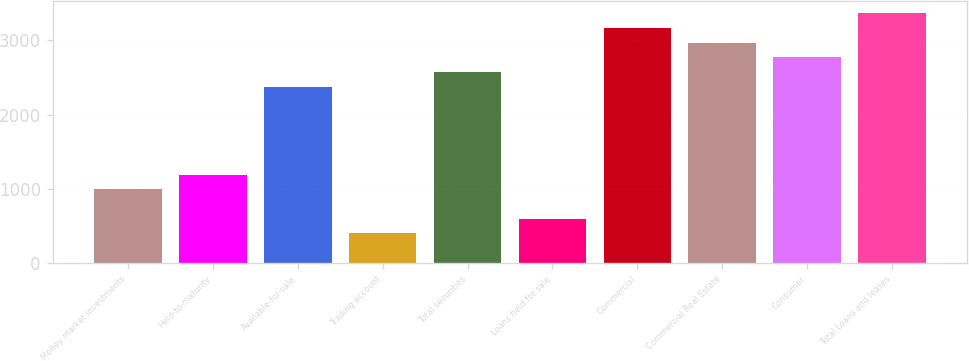Convert chart. <chart><loc_0><loc_0><loc_500><loc_500><bar_chart><fcel>Money market investments<fcel>Held-to-maturity<fcel>Available-for-sale<fcel>Trading account<fcel>Total securities<fcel>Loans held for sale<fcel>Commercial<fcel>Commercial Real Estate<fcel>Consumer<fcel>Total Loans and leases<nl><fcel>989.95<fcel>1187.88<fcel>2375.46<fcel>396.16<fcel>2573.39<fcel>594.09<fcel>3167.18<fcel>2969.25<fcel>2771.32<fcel>3365.11<nl></chart> 